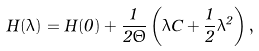Convert formula to latex. <formula><loc_0><loc_0><loc_500><loc_500>H ( \lambda ) = H ( 0 ) + \frac { 1 } { 2 \Theta } \left ( \lambda C + \frac { 1 } { 2 } \lambda ^ { 2 } \right ) ,</formula> 